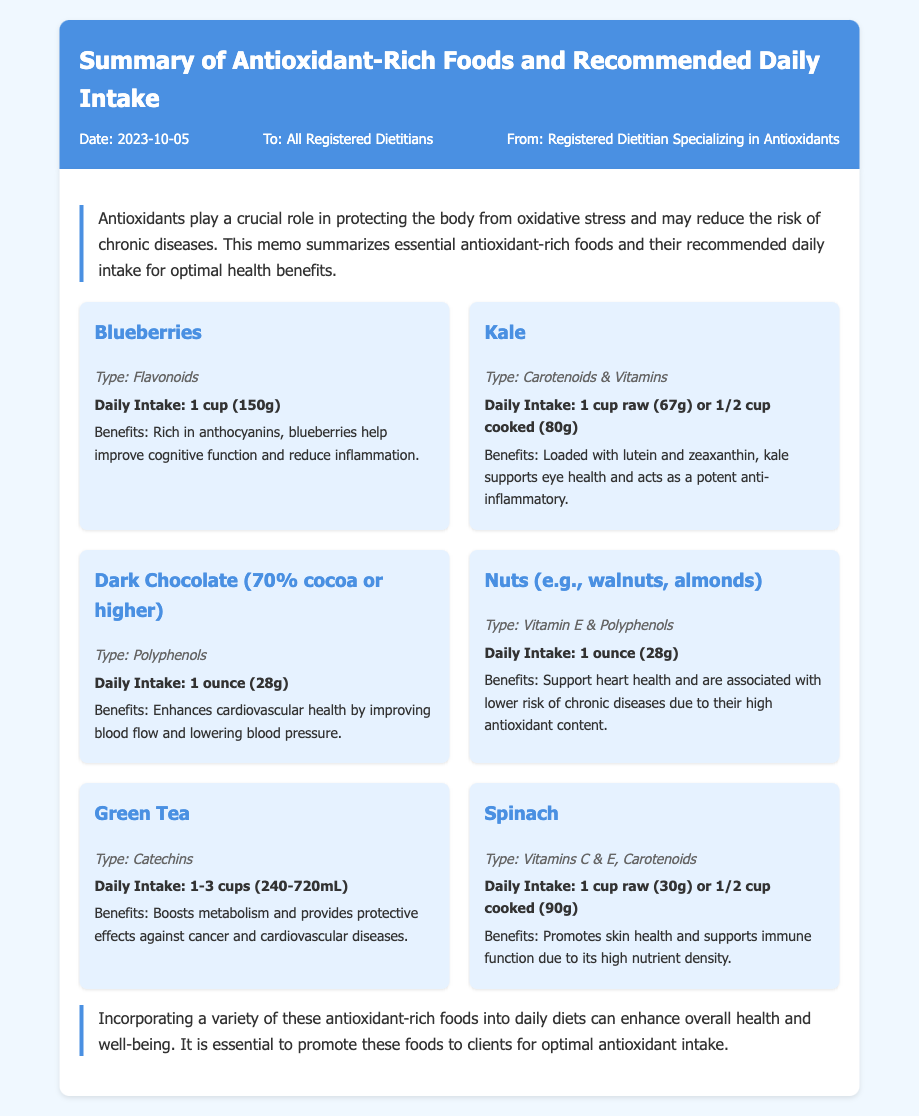What date was the memo created? The date is mentioned in the memo meta section, indicating when it was written.
Answer: 2023-10-05 Who is the memo addressed to? The recipient of the memo is noted in the memo meta section, where it lists the audience.
Answer: All Registered Dietitians What is the daily intake recommendation for blueberries? The specific daily intake for blueberries is provided within the content section, detailing the amount needed for optimal health.
Answer: 1 cup (150g) What type of antioxidants do nuts provide? The memo specifies the types of antioxidants found in nuts, which are categorized in their content.
Answer: Vitamin E & Polyphenols How many cups of green tea are recommended daily? The recommendation for green tea is given as a range in the daily intake section.
Answer: 1-3 cups (240-720mL) Which food mentioned is known to improve cognitive function? The benefits section describes which food aids cognitive function, highlighting its specific advantages.
Answer: Blueberries What are the benefits of dark chocolate? The memo outlines the health benefits of dark chocolate, summarizing its impact on health.
Answer: Enhances cardiovascular health What type of memo is this document? The document's title and structure reflect its purpose and format, distinguishing it from other document types.
Answer: Memo What type of food is kale categorized under? The type of antioxidants found in kale is directly referenced in its description within the list of foods.
Answer: Carotenoids & Vitamins 